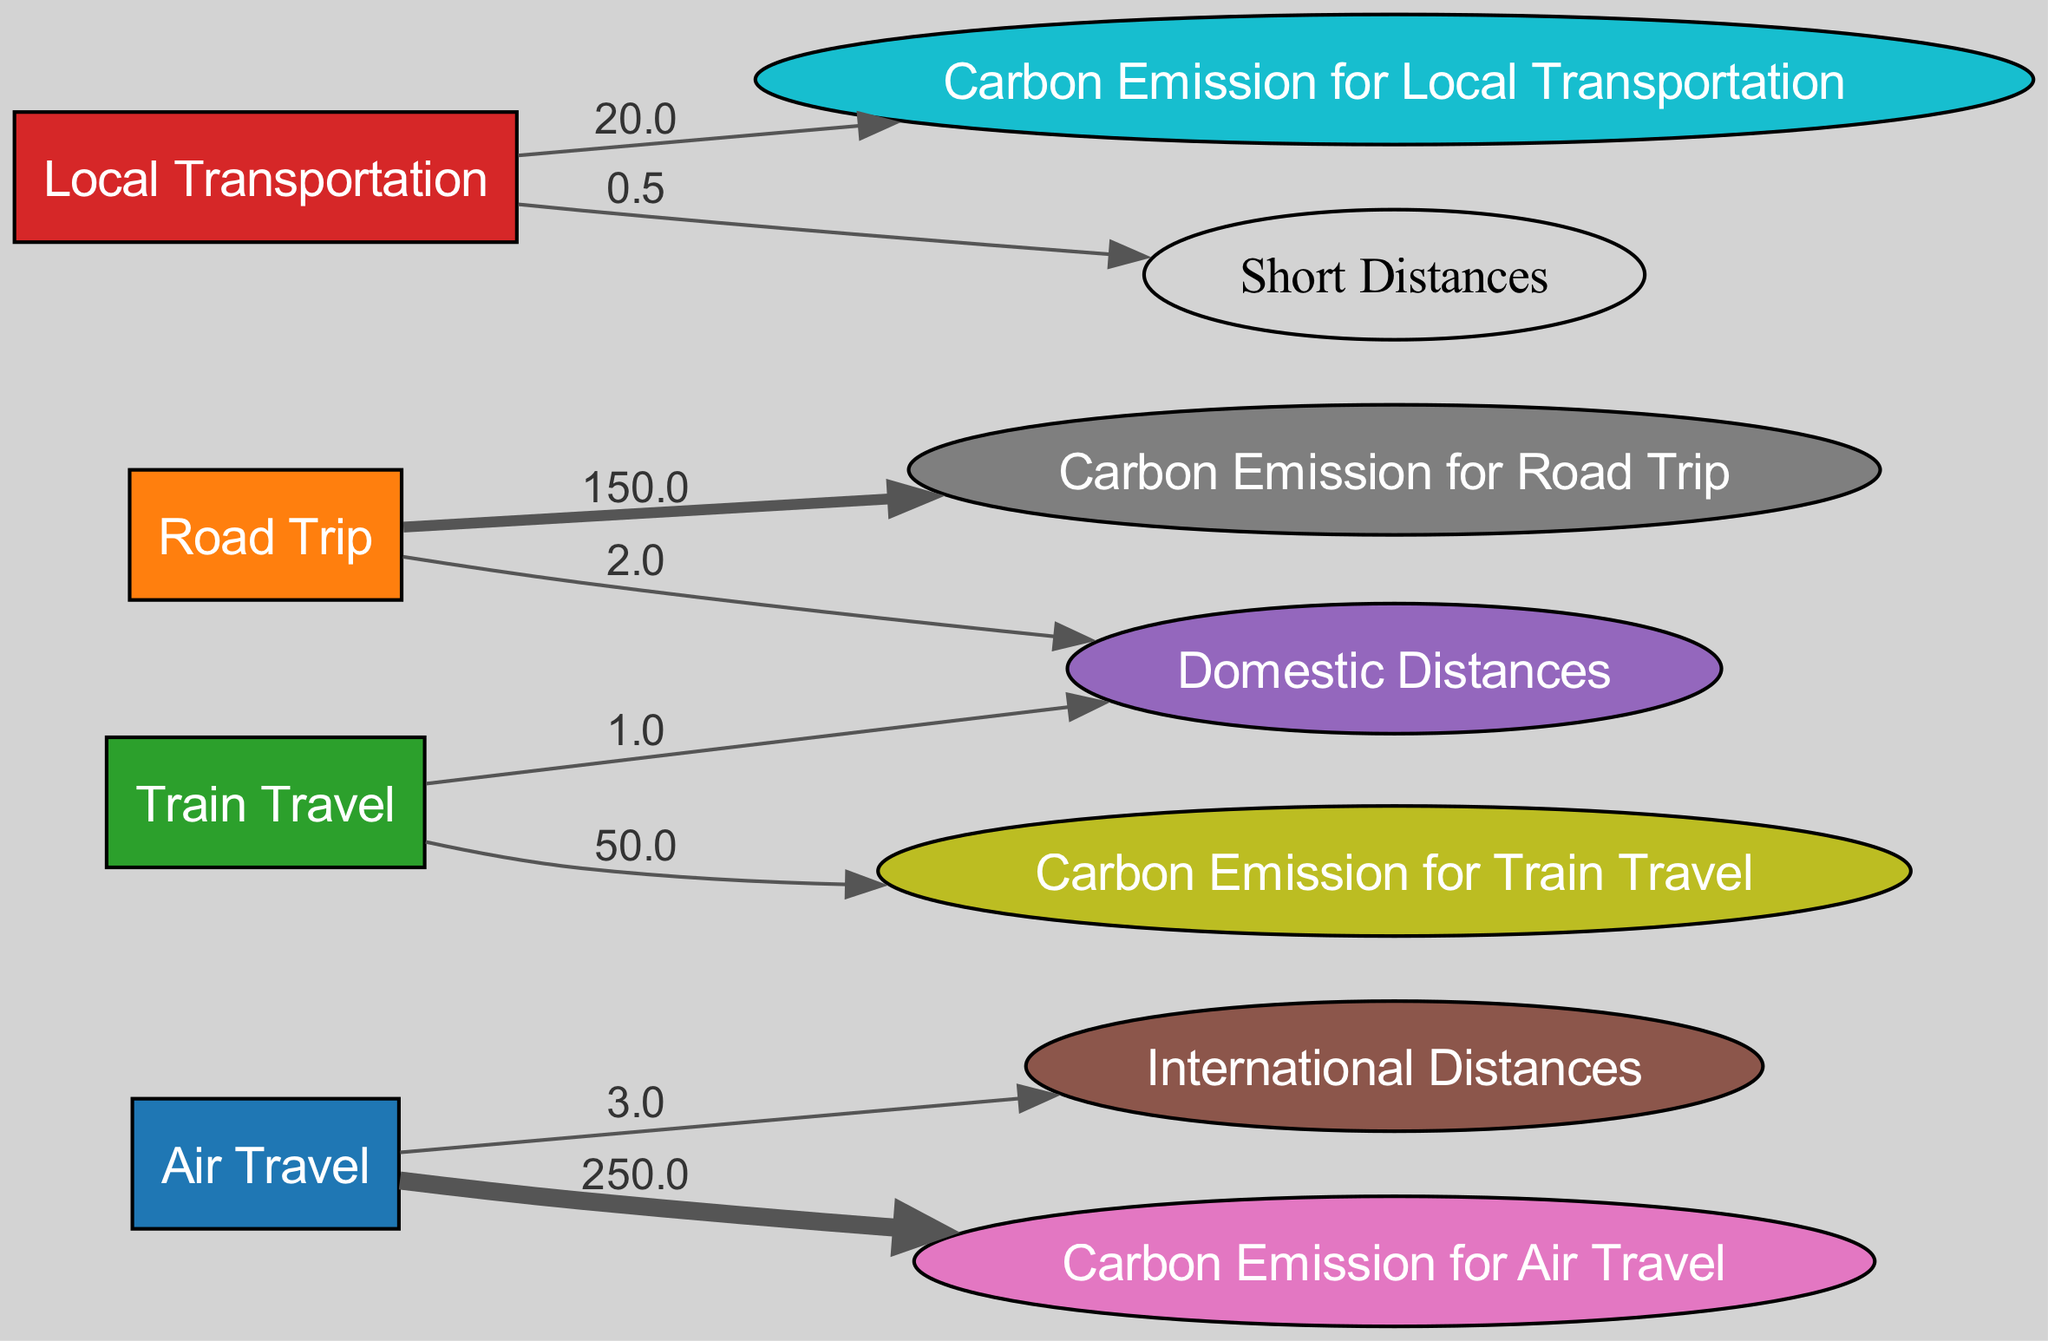What is the carbon emission value for Air Travel? The diagram shows a direct link from "Air Travel" to "Carbon Emission for Air Travel" with a value of 250.
Answer: 250 How many transport methods are there? The diagram lists four transport methods: Air Travel, Road Trip, Train Travel, and Local Transportation, which totals to four.
Answer: 4 Which transport method is associated with International Distances? There is a direct link from "Air Travel" to "International Distances," making Air Travel the associated method.
Answer: Air Travel What is the penwidth representing for the Road Trip to Carbon Emission link? The value for Road Trip carbon emission is 150. When scaled, it would represent a penwidth greater than the minimum (1) but less than 5. The exact penwidth will be calculated as max(1, min(5, 150 / 50)) = 3.
Answer: 3 Which method has the least carbon emission? Among the carbon emissions listed, Local Transportation has the least value of 20.
Answer: 20 Which distance category is most frequently associated with domestic travel? "Road Trip" and "Train Travel" are both linked to "Domestic Distances," identifying it as the most frequently associated distance category for domestic travel.
Answer: Domestic Distances If a traveler uses Local Transportation, what is their carbon emission value? The diagram shows a direct link from "Local Transportation" to "Carbon Emission for Local Transportation" with a value of 20.
Answer: 20 Which transport methods produce carbon emissions greater than 100? "Air Travel" with 250 and "Road Trip" with 150 both have carbon emissions greater than 100.
Answer: Air Travel, Road Trip Based on the diagram, what is the total carbon emission from all transportation methods combined? By adding the values for carbon emissions: 250 (Air Travel) + 150 (Road Trip) + 50 (Train Travel) + 20 (Local Transportation) gives a total of 470.
Answer: 470 